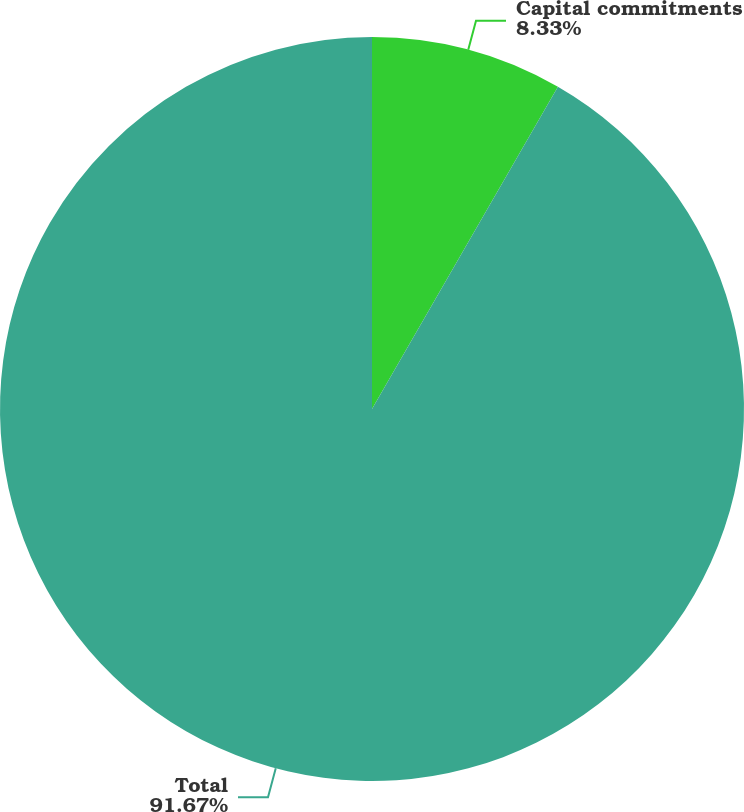<chart> <loc_0><loc_0><loc_500><loc_500><pie_chart><fcel>Capital commitments<fcel>Total<nl><fcel>8.33%<fcel>91.67%<nl></chart> 